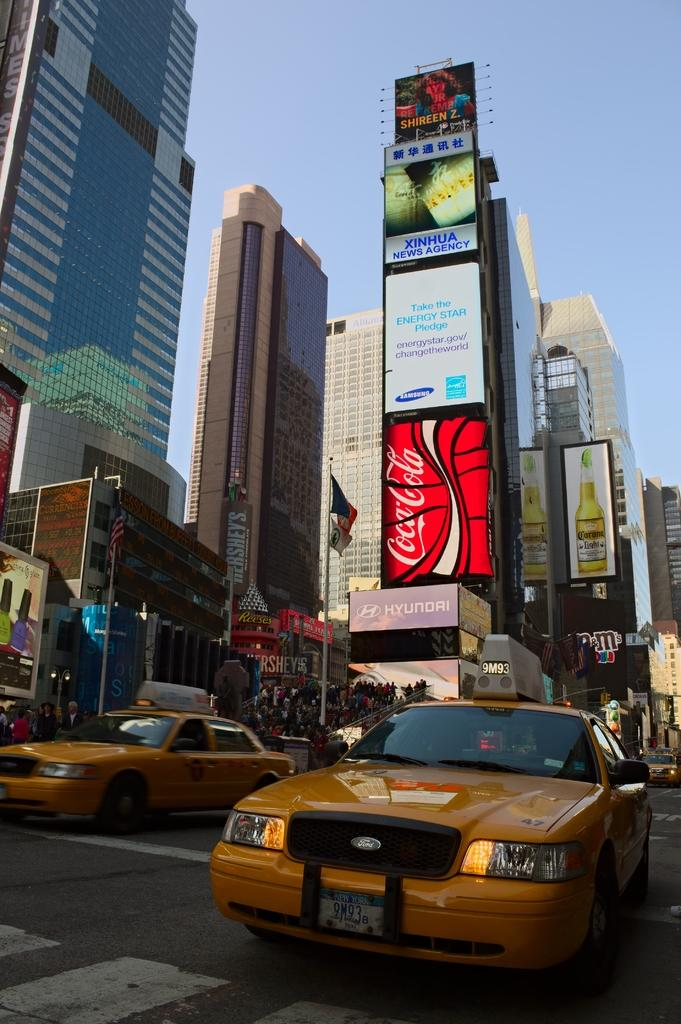<image>
Present a compact description of the photo's key features. A Hyundai ad sits below a Coca-Cola ad on a busy street. 